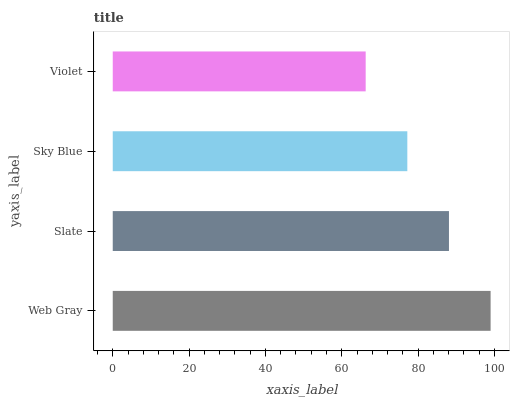Is Violet the minimum?
Answer yes or no. Yes. Is Web Gray the maximum?
Answer yes or no. Yes. Is Slate the minimum?
Answer yes or no. No. Is Slate the maximum?
Answer yes or no. No. Is Web Gray greater than Slate?
Answer yes or no. Yes. Is Slate less than Web Gray?
Answer yes or no. Yes. Is Slate greater than Web Gray?
Answer yes or no. No. Is Web Gray less than Slate?
Answer yes or no. No. Is Slate the high median?
Answer yes or no. Yes. Is Sky Blue the low median?
Answer yes or no. Yes. Is Sky Blue the high median?
Answer yes or no. No. Is Web Gray the low median?
Answer yes or no. No. 